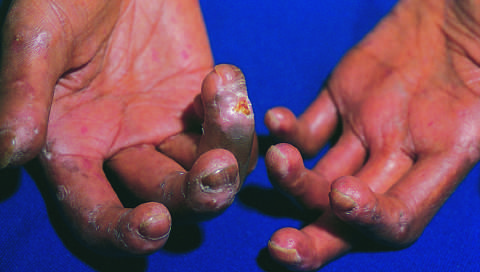what has loss of blood supply led to?
Answer the question using a single word or phrase. Cutaneous ulcerations 